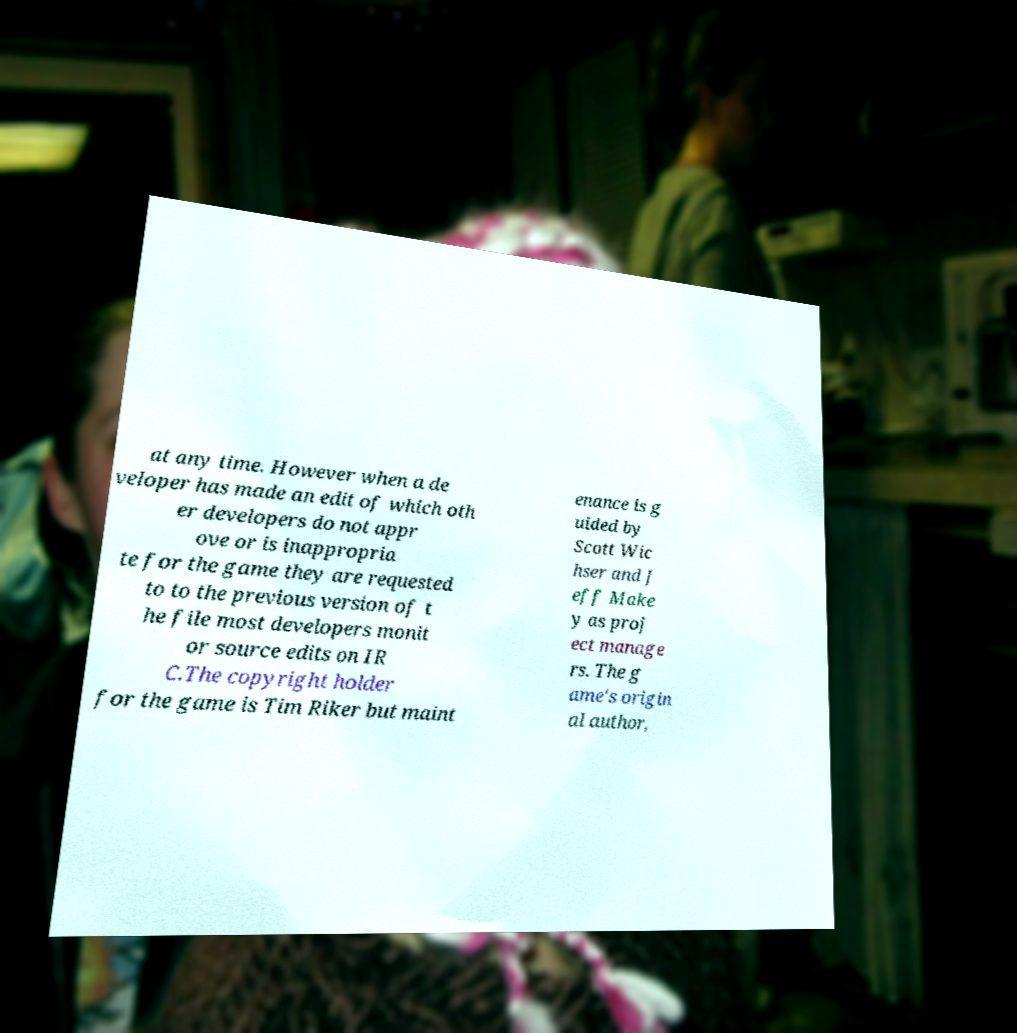Can you accurately transcribe the text from the provided image for me? at any time. However when a de veloper has made an edit of which oth er developers do not appr ove or is inappropria te for the game they are requested to to the previous version of t he file most developers monit or source edits on IR C.The copyright holder for the game is Tim Riker but maint enance is g uided by Scott Wic hser and J eff Make y as proj ect manage rs. The g ame's origin al author, 